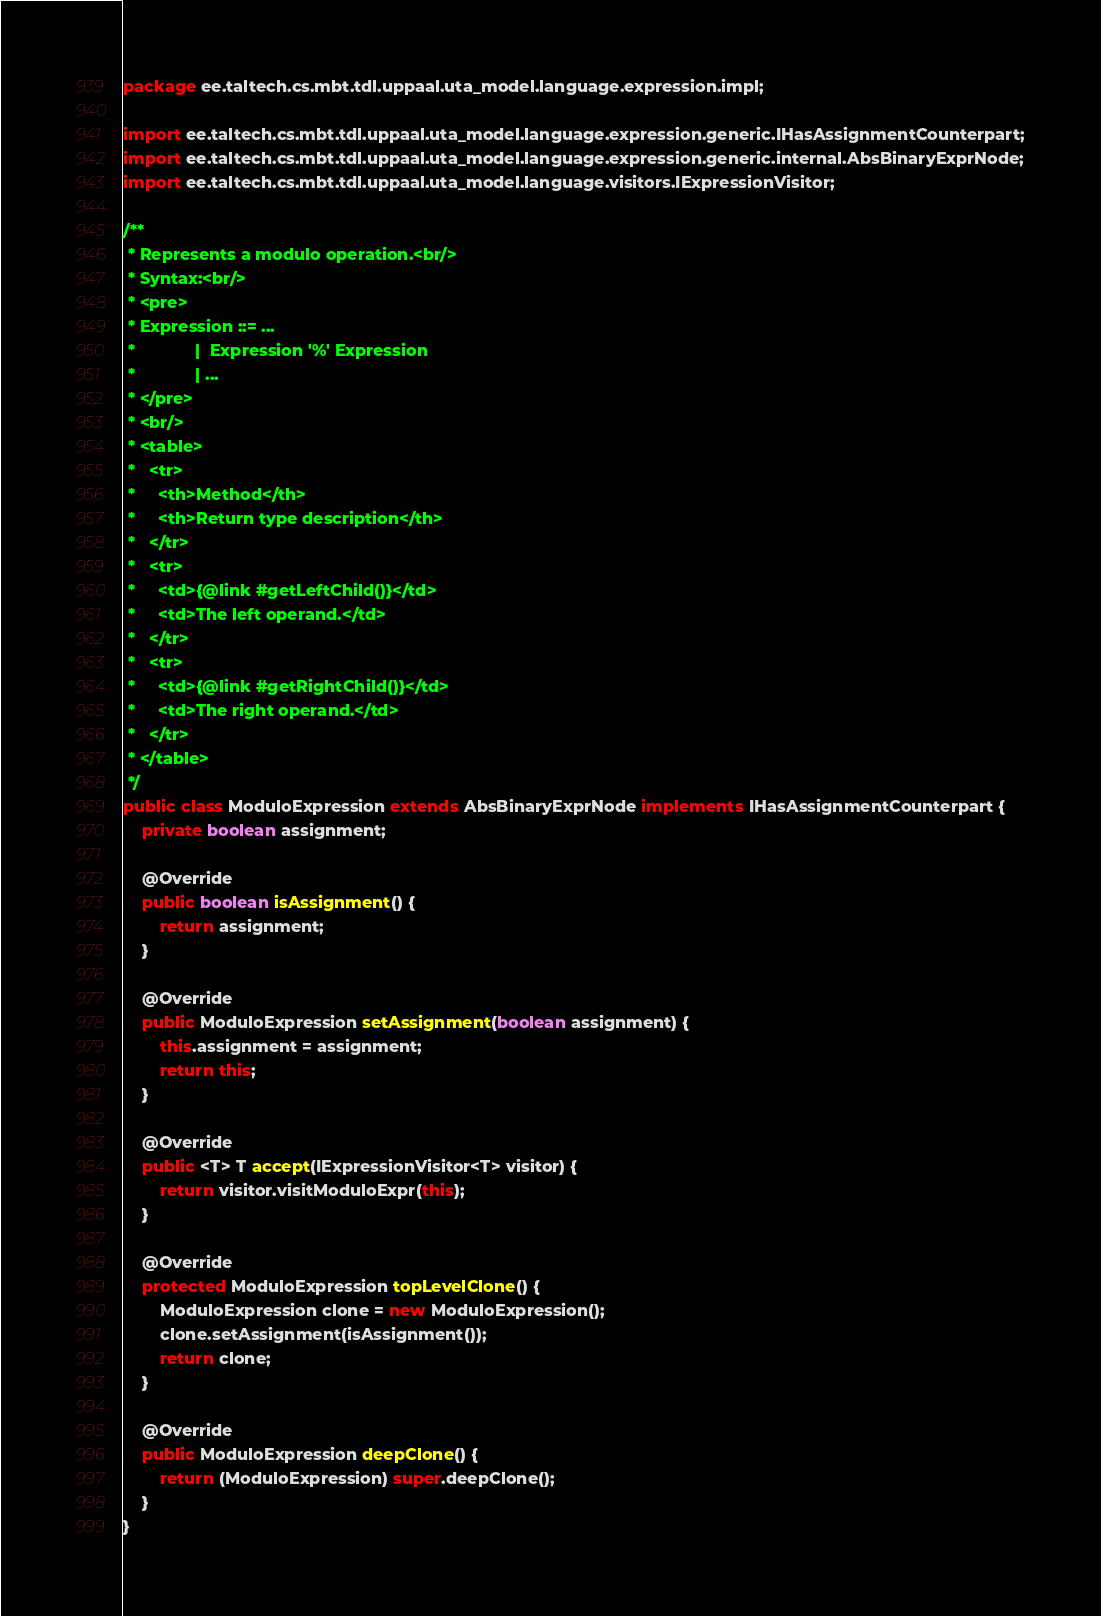<code> <loc_0><loc_0><loc_500><loc_500><_Java_>package ee.taltech.cs.mbt.tdl.uppaal.uta_model.language.expression.impl;

import ee.taltech.cs.mbt.tdl.uppaal.uta_model.language.expression.generic.IHasAssignmentCounterpart;
import ee.taltech.cs.mbt.tdl.uppaal.uta_model.language.expression.generic.internal.AbsBinaryExprNode;
import ee.taltech.cs.mbt.tdl.uppaal.uta_model.language.visitors.IExpressionVisitor;

/**
 * Represents a modulo operation.<br/>
 * Syntax:<br/>
 * <pre>
 * Expression ::= ...
 *             |  Expression '%' Expression
 *             | ...
 * </pre>
 * <br/>
 * <table>
 *   <tr>
 *     <th>Method</th>
 *     <th>Return type description</th>
 *   </tr>
 *   <tr>
 *     <td>{@link #getLeftChild()}</td>
 *     <td>The left operand.</td>
 *   </tr>
 *   <tr>
 *     <td>{@link #getRightChild()}</td>
 *     <td>The right operand.</td>
 *   </tr>
 * </table>
 */
public class ModuloExpression extends AbsBinaryExprNode implements IHasAssignmentCounterpart {
	private boolean assignment;

	@Override
	public boolean isAssignment() {
		return assignment;
	}

	@Override
	public ModuloExpression setAssignment(boolean assignment) {
		this.assignment = assignment;
		return this;
	}

	@Override
	public <T> T accept(IExpressionVisitor<T> visitor) {
		return visitor.visitModuloExpr(this);
	}

	@Override
	protected ModuloExpression topLevelClone() {
		ModuloExpression clone = new ModuloExpression();
		clone.setAssignment(isAssignment());
		return clone;
	}

	@Override
	public ModuloExpression deepClone() {
		return (ModuloExpression) super.deepClone();
	}
}
</code> 